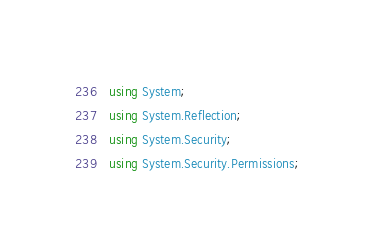<code> <loc_0><loc_0><loc_500><loc_500><_C#_>using System;
using System.Reflection;
using System.Security;
using System.Security.Permissions;
</code> 